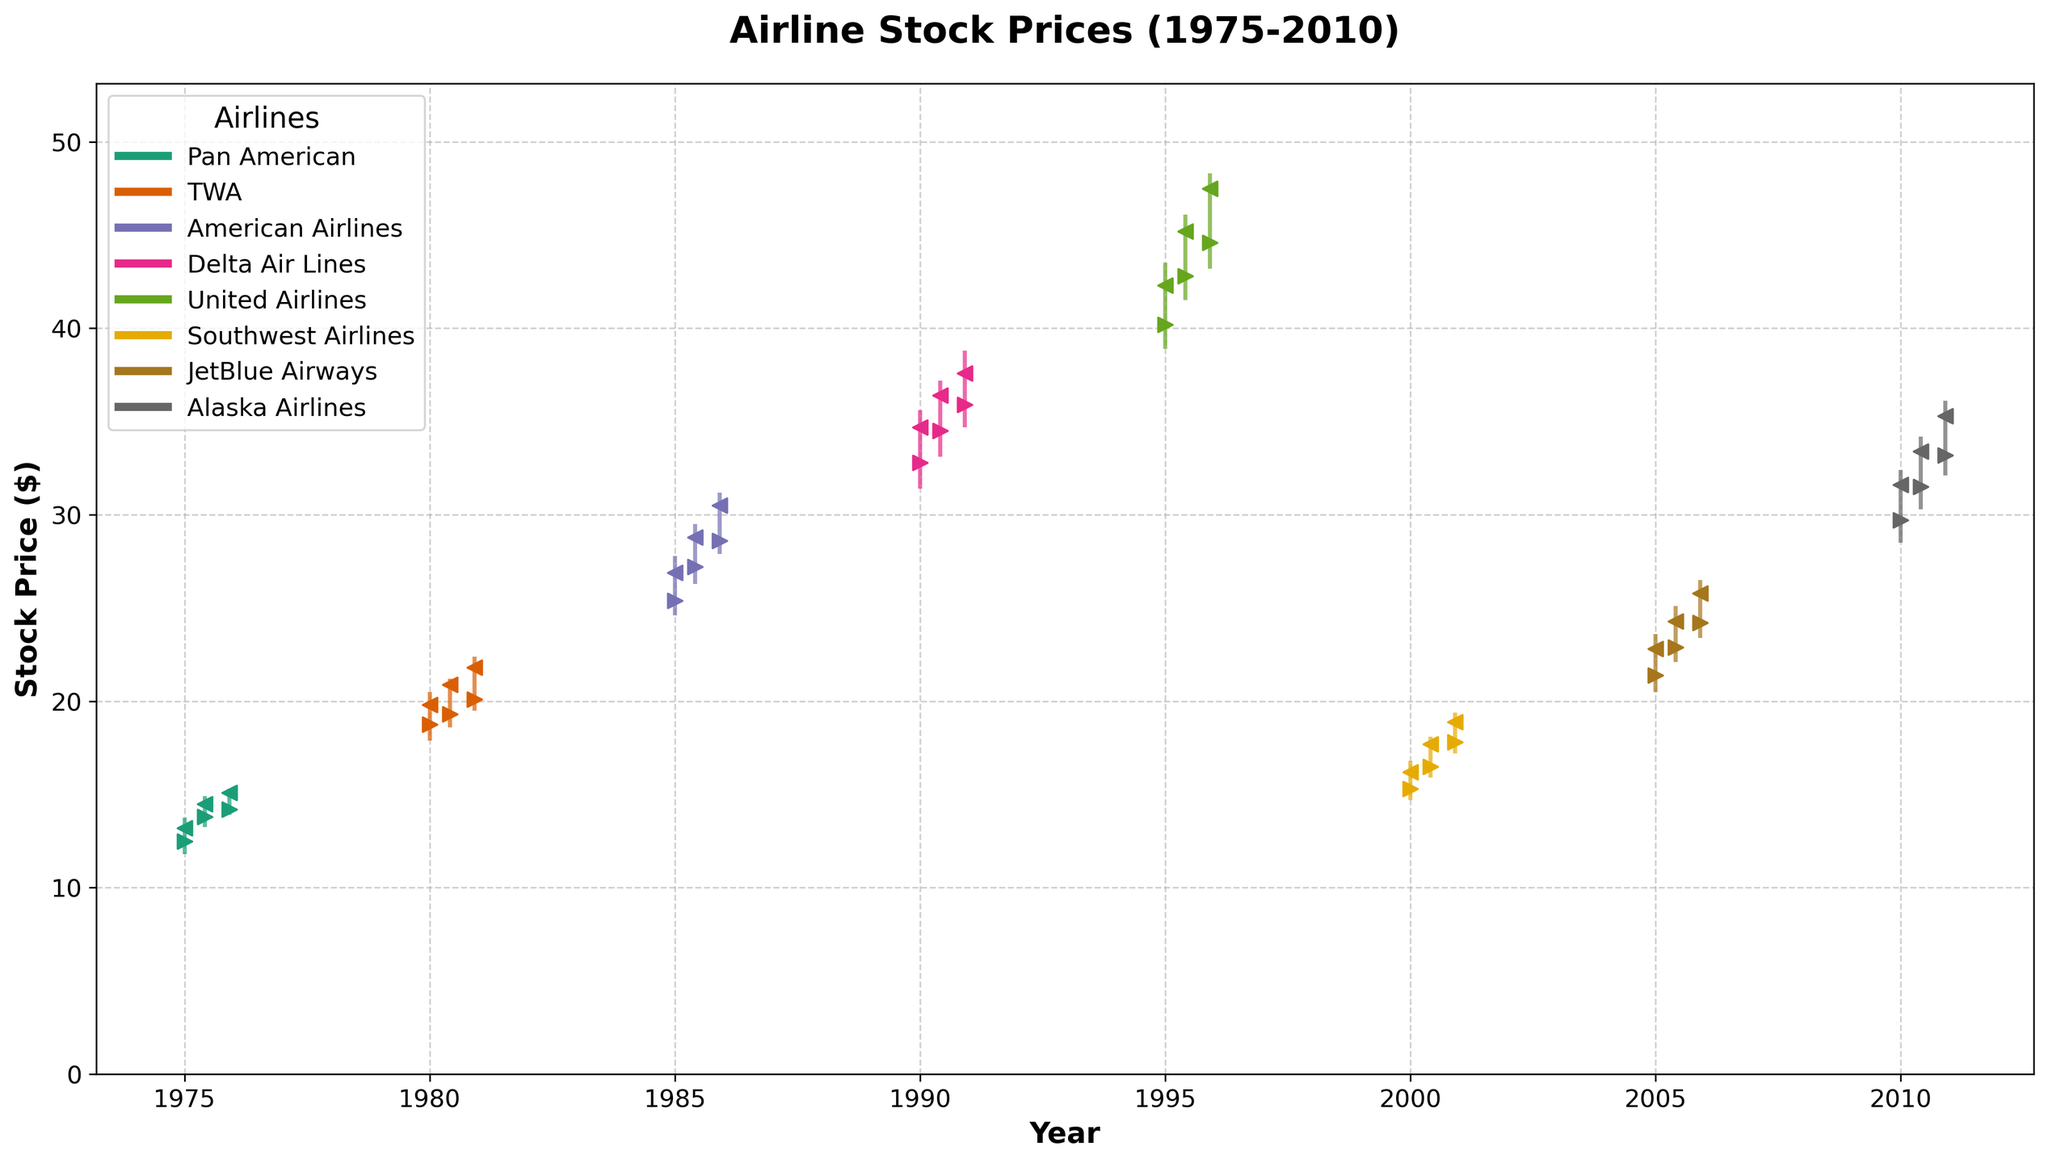How many airlines are represented in the chart? The chart includes data points that are color-coded for different airlines. Count the number of unique colors given in the legend.
Answer: 7 What's the title of the chart? Look at the top of the chart where the title is usually displayed.
Answer: Airline Stock Prices (1975-2010) Which airline had the highest stock price and when? Examine all the data points and identify the highest point on the y-axis, then track which airline and date this data point corresponds to.
Answer: United Airlines in December 1995 What is the average closing price of American Airlines in 1985? Look at the closing prices for American Airlines in the two data points for 1985. Sum these closing prices and divide by the number of data points. (26.90 + 30.50)/2 = 28.70
Answer: 28.70 Compare the stock trends of Pan American in 1975 and TWA in 1980. TWA in 1980 shows an increasing trend with opening prices staying lower than closing prices, while Pan American also shows growth through the year but the increase is steadier. Pan American starts the year lower and ends higher, similar to TWA.
Answer: Both airlines show growth, with TWA having steeper increases What was the lowest stock price for Delta Air Lines in 1990? Examine the 'Low' values for Delta Air Lines in 1990.
Answer: 31.40 Which airline showed the highest increase in stock price within one year? Compare the differences between the 'Open' and 'Close' prices for all airlines across all years listed. Identify the maximum increase.
Answer: TWA in 1980 (19.80 - 17.90 = 1.90 in December) How did the stock price of JetBlue Airways change from June to December 2005? Look at the 'Open' and 'Close' prices for JetBlue Airways in June and December 2005. Compare the prices to find the change.
Answer: The stock increased from 22.90 to 25.80 What is the consistent trend seen in Southwest Airlines' stock prices in 2000? Observe the pattern of opening and closing prices for Southwest Airlines within 2000. They always close higher than they open.
Answer: Closing prices are higher than opening prices throughout the year How do the stock prices of Alaska Airlines in 2010 compare to American Airlines in 1985? Compare the closing prices of Alaska Airlines in 2010 with American Airlines in 1985. Alaska Airlines ranges from 31.60 to 35.30, while American Airlines ranges from 26.90 to 30.50.
Answer: Alaska Airlines in 2010 had consistently higher closing prices compared to American Airlines in 1985 